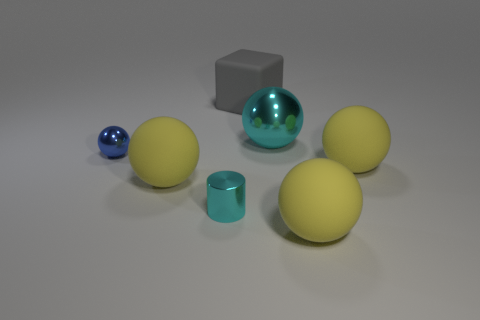Are there any cyan metallic objects? Yes, there is one cyan metallic object in the image. It appears to be a reflective sphere at the center, displaying characteristics of a metallic surface with a cyan hue. 